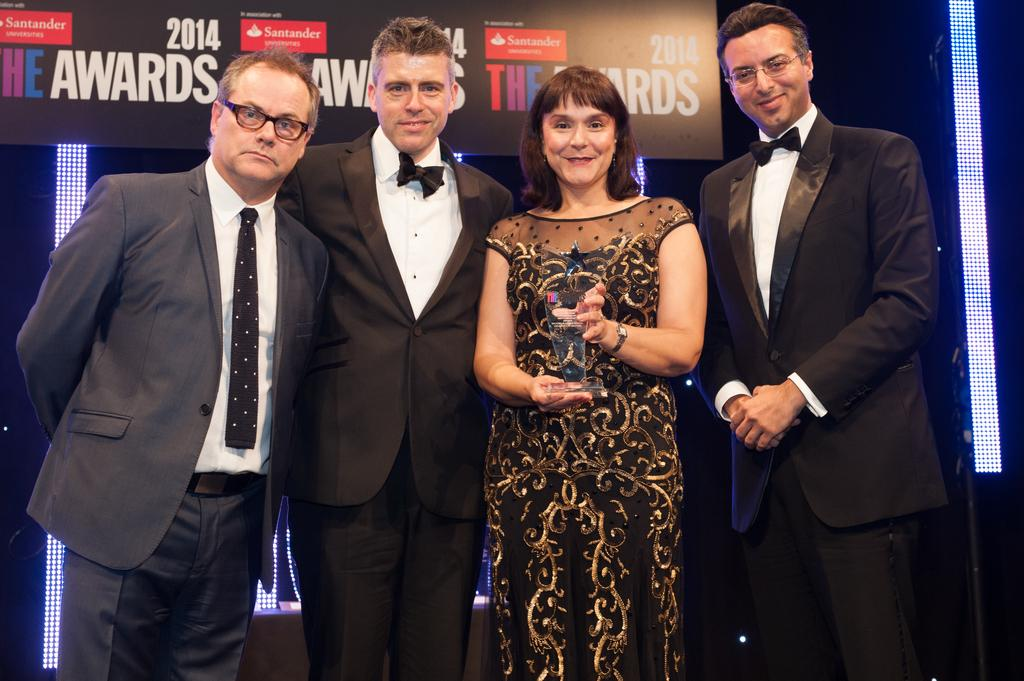How many people are present in the image? There are four people standing in the image. What is the woman holding in the image? The woman is holding a trophy. What can be seen in the background of the image? There is a hoarding and lights in the background of the image. What type of beast can be seen in the image? There is no beast present in the image. What advice might the woman's grandmother give her in the image? There is no grandmother present in the image, so it is not possible to determine what advice she might give. 